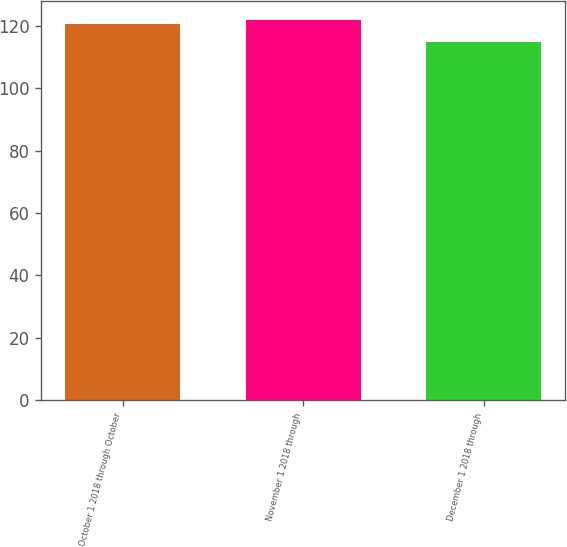Convert chart to OTSL. <chart><loc_0><loc_0><loc_500><loc_500><bar_chart><fcel>October 1 2018 through October<fcel>November 1 2018 through<fcel>December 1 2018 through<nl><fcel>120.55<fcel>121.93<fcel>114.76<nl></chart> 